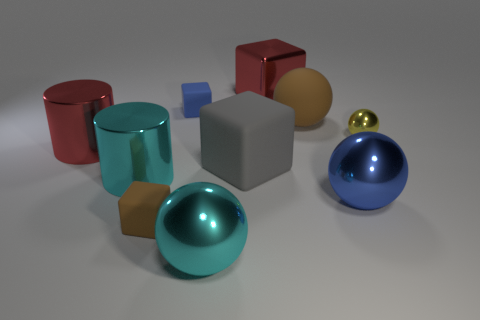Is the color of the small thing that is in front of the red cylinder the same as the large matte sphere?
Offer a very short reply. Yes. There is a shiny thing that is both to the right of the red shiny block and behind the blue metallic ball; what is its size?
Keep it short and to the point. Small. Is the number of large blocks that are in front of the big gray cube greater than the number of blocks?
Give a very brief answer. No. How many objects are either cyan matte things or large metallic things that are in front of the red block?
Ensure brevity in your answer.  4. Is the number of large balls in front of the small brown block greater than the number of small yellow things that are in front of the yellow metal object?
Keep it short and to the point. Yes. There is a cylinder that is in front of the gray rubber thing to the left of the red object that is behind the matte ball; what is its material?
Keep it short and to the point. Metal. The yellow thing that is the same material as the large blue object is what shape?
Your response must be concise. Sphere. There is a blue shiny ball in front of the red metal cylinder; is there a tiny object on the left side of it?
Your response must be concise. Yes. The cyan ball has what size?
Provide a short and direct response. Large. How many objects are yellow objects or tiny blue rubber things?
Ensure brevity in your answer.  2. 